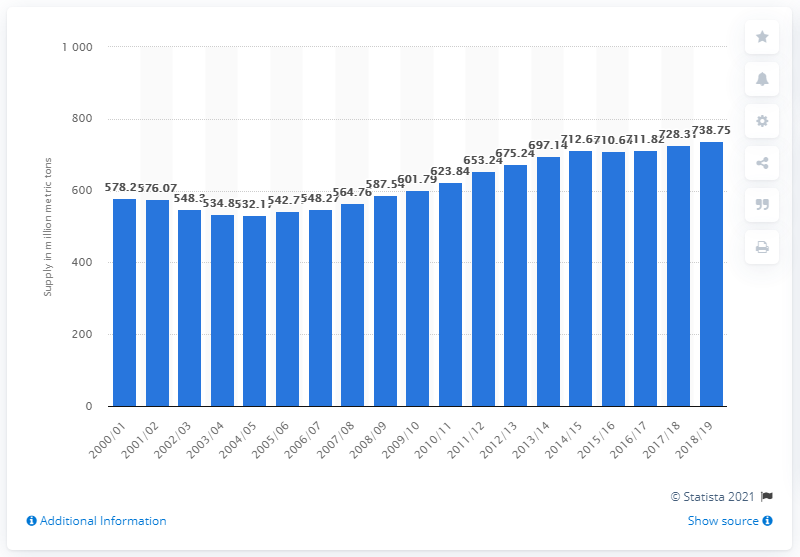Point out several critical features in this image. In 2018/2019, the global supply of rice was 738.75 million metric tons. 